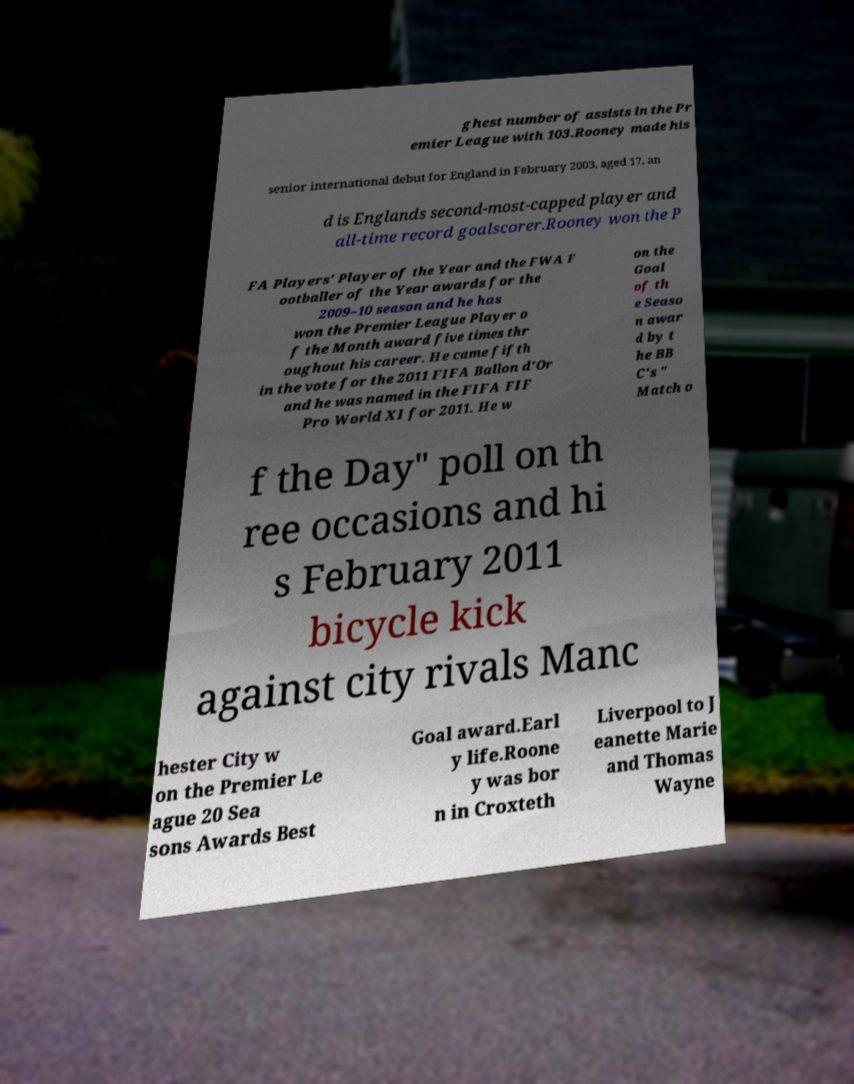Can you read and provide the text displayed in the image?This photo seems to have some interesting text. Can you extract and type it out for me? ghest number of assists in the Pr emier League with 103.Rooney made his senior international debut for England in February 2003, aged 17, an d is Englands second-most-capped player and all-time record goalscorer.Rooney won the P FA Players' Player of the Year and the FWA F ootballer of the Year awards for the 2009–10 season and he has won the Premier League Player o f the Month award five times thr oughout his career. He came fifth in the vote for the 2011 FIFA Ballon d'Or and he was named in the FIFA FIF Pro World XI for 2011. He w on the Goal of th e Seaso n awar d by t he BB C's " Match o f the Day" poll on th ree occasions and hi s February 2011 bicycle kick against city rivals Manc hester City w on the Premier Le ague 20 Sea sons Awards Best Goal award.Earl y life.Roone y was bor n in Croxteth Liverpool to J eanette Marie and Thomas Wayne 